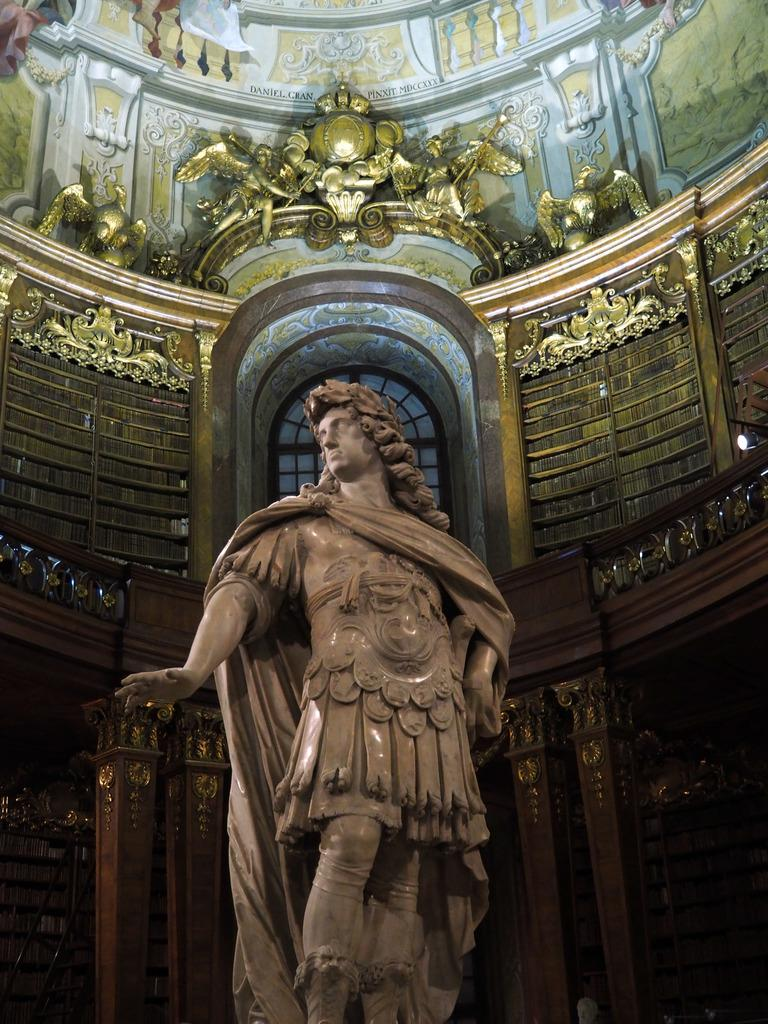What is the main subject of the image? There is a sculpture in the image. What can be seen in the background of the image? There is a wall and statues in the background of the image. What type of yak can be seen in the image? There is no yak present in the image. What material is the sculpture made of in the image? The provided facts do not mention the material of the sculpture, so we cannot determine its composition from the image. 